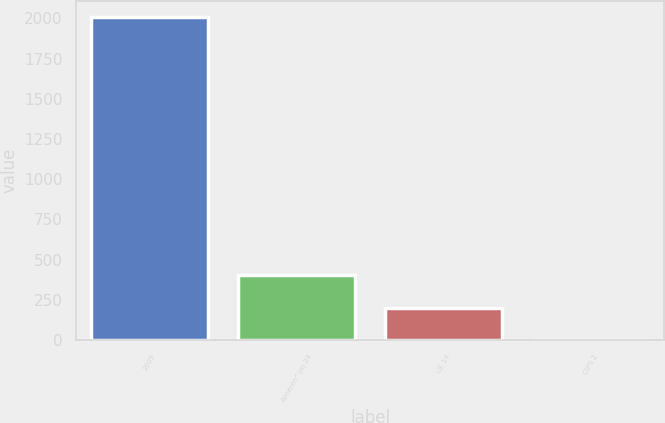Convert chart. <chart><loc_0><loc_0><loc_500><loc_500><bar_chart><fcel>2009<fcel>Ameren^(a) 24<fcel>UE 14<fcel>CIPS 2<nl><fcel>2007<fcel>402.2<fcel>201.6<fcel>1<nl></chart> 